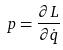Convert formula to latex. <formula><loc_0><loc_0><loc_500><loc_500>p = \frac { \partial L } { \partial \dot { q } }</formula> 